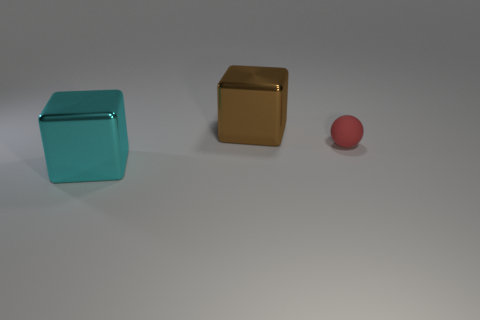Add 1 rubber spheres. How many objects exist? 4 Subtract all spheres. How many objects are left? 2 Add 2 cyan metal objects. How many cyan metal objects are left? 3 Add 3 tiny red balls. How many tiny red balls exist? 4 Subtract 1 cyan blocks. How many objects are left? 2 Subtract all large purple blocks. Subtract all big objects. How many objects are left? 1 